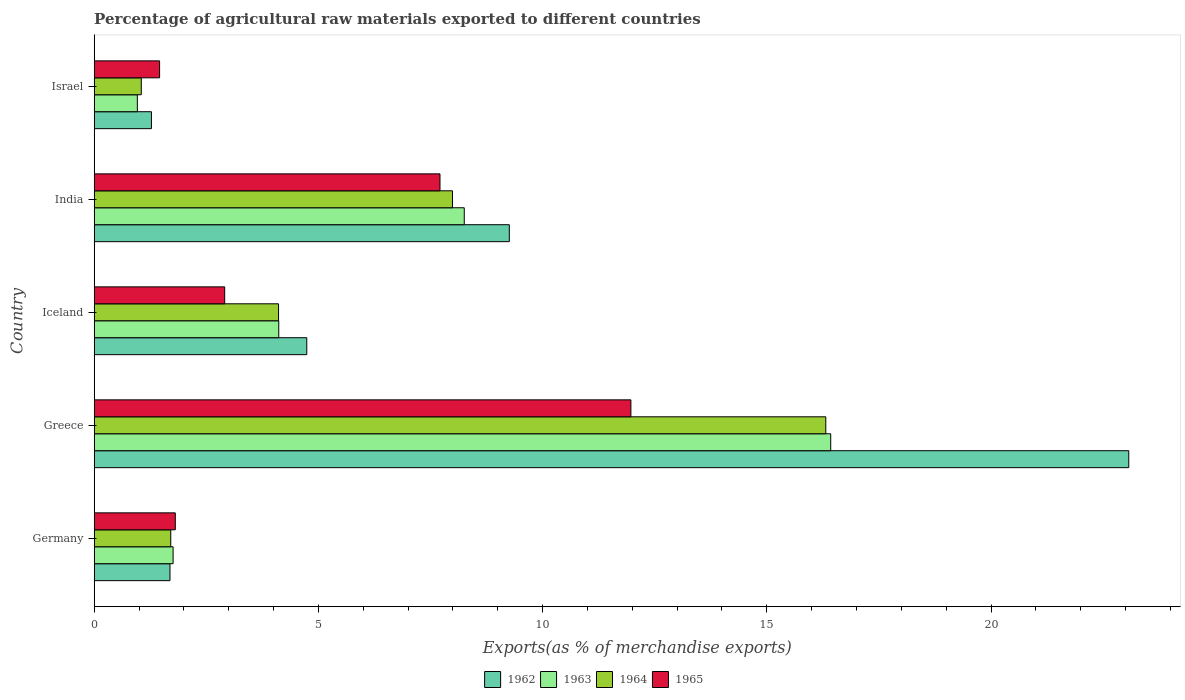Are the number of bars on each tick of the Y-axis equal?
Provide a short and direct response. Yes. How many bars are there on the 3rd tick from the top?
Provide a succinct answer. 4. How many bars are there on the 5th tick from the bottom?
Provide a succinct answer. 4. What is the label of the 1st group of bars from the top?
Provide a short and direct response. Israel. What is the percentage of exports to different countries in 1962 in Germany?
Your answer should be very brief. 1.69. Across all countries, what is the maximum percentage of exports to different countries in 1963?
Offer a very short reply. 16.43. Across all countries, what is the minimum percentage of exports to different countries in 1963?
Provide a short and direct response. 0.96. In which country was the percentage of exports to different countries in 1964 maximum?
Keep it short and to the point. Greece. In which country was the percentage of exports to different countries in 1962 minimum?
Make the answer very short. Israel. What is the total percentage of exports to different countries in 1964 in the graph?
Keep it short and to the point. 31.17. What is the difference between the percentage of exports to different countries in 1964 in Germany and that in Iceland?
Ensure brevity in your answer.  -2.4. What is the difference between the percentage of exports to different countries in 1963 in India and the percentage of exports to different countries in 1964 in Israel?
Your response must be concise. 7.2. What is the average percentage of exports to different countries in 1964 per country?
Your response must be concise. 6.23. What is the difference between the percentage of exports to different countries in 1962 and percentage of exports to different countries in 1963 in Israel?
Give a very brief answer. 0.31. In how many countries, is the percentage of exports to different countries in 1965 greater than 8 %?
Your response must be concise. 1. What is the ratio of the percentage of exports to different countries in 1962 in Greece to that in Israel?
Your response must be concise. 18.07. Is the difference between the percentage of exports to different countries in 1962 in Iceland and Israel greater than the difference between the percentage of exports to different countries in 1963 in Iceland and Israel?
Provide a short and direct response. Yes. What is the difference between the highest and the second highest percentage of exports to different countries in 1965?
Offer a very short reply. 4.26. What is the difference between the highest and the lowest percentage of exports to different countries in 1963?
Offer a terse response. 15.46. In how many countries, is the percentage of exports to different countries in 1963 greater than the average percentage of exports to different countries in 1963 taken over all countries?
Keep it short and to the point. 2. What does the 1st bar from the bottom in Germany represents?
Ensure brevity in your answer.  1962. Is it the case that in every country, the sum of the percentage of exports to different countries in 1962 and percentage of exports to different countries in 1965 is greater than the percentage of exports to different countries in 1963?
Your answer should be very brief. Yes. How many bars are there?
Offer a terse response. 20. Are all the bars in the graph horizontal?
Offer a very short reply. Yes. Are the values on the major ticks of X-axis written in scientific E-notation?
Offer a terse response. No. Does the graph contain any zero values?
Provide a succinct answer. No. Where does the legend appear in the graph?
Provide a succinct answer. Bottom center. How many legend labels are there?
Your answer should be very brief. 4. What is the title of the graph?
Your response must be concise. Percentage of agricultural raw materials exported to different countries. What is the label or title of the X-axis?
Provide a succinct answer. Exports(as % of merchandise exports). What is the label or title of the Y-axis?
Your answer should be compact. Country. What is the Exports(as % of merchandise exports) in 1962 in Germany?
Provide a short and direct response. 1.69. What is the Exports(as % of merchandise exports) in 1963 in Germany?
Provide a succinct answer. 1.76. What is the Exports(as % of merchandise exports) of 1964 in Germany?
Keep it short and to the point. 1.71. What is the Exports(as % of merchandise exports) of 1965 in Germany?
Your answer should be compact. 1.81. What is the Exports(as % of merchandise exports) of 1962 in Greece?
Make the answer very short. 23.07. What is the Exports(as % of merchandise exports) of 1963 in Greece?
Your answer should be compact. 16.43. What is the Exports(as % of merchandise exports) of 1964 in Greece?
Your answer should be compact. 16.32. What is the Exports(as % of merchandise exports) in 1965 in Greece?
Your response must be concise. 11.97. What is the Exports(as % of merchandise exports) of 1962 in Iceland?
Make the answer very short. 4.74. What is the Exports(as % of merchandise exports) of 1963 in Iceland?
Your answer should be very brief. 4.12. What is the Exports(as % of merchandise exports) of 1964 in Iceland?
Ensure brevity in your answer.  4.11. What is the Exports(as % of merchandise exports) in 1965 in Iceland?
Offer a very short reply. 2.91. What is the Exports(as % of merchandise exports) of 1962 in India?
Your answer should be compact. 9.26. What is the Exports(as % of merchandise exports) in 1963 in India?
Your answer should be compact. 8.25. What is the Exports(as % of merchandise exports) in 1964 in India?
Your answer should be compact. 7.99. What is the Exports(as % of merchandise exports) of 1965 in India?
Offer a very short reply. 7.71. What is the Exports(as % of merchandise exports) of 1962 in Israel?
Give a very brief answer. 1.28. What is the Exports(as % of merchandise exports) in 1963 in Israel?
Ensure brevity in your answer.  0.96. What is the Exports(as % of merchandise exports) of 1964 in Israel?
Ensure brevity in your answer.  1.05. What is the Exports(as % of merchandise exports) in 1965 in Israel?
Ensure brevity in your answer.  1.46. Across all countries, what is the maximum Exports(as % of merchandise exports) of 1962?
Keep it short and to the point. 23.07. Across all countries, what is the maximum Exports(as % of merchandise exports) in 1963?
Your response must be concise. 16.43. Across all countries, what is the maximum Exports(as % of merchandise exports) of 1964?
Offer a very short reply. 16.32. Across all countries, what is the maximum Exports(as % of merchandise exports) of 1965?
Provide a succinct answer. 11.97. Across all countries, what is the minimum Exports(as % of merchandise exports) in 1962?
Your answer should be very brief. 1.28. Across all countries, what is the minimum Exports(as % of merchandise exports) in 1963?
Your response must be concise. 0.96. Across all countries, what is the minimum Exports(as % of merchandise exports) in 1964?
Offer a terse response. 1.05. Across all countries, what is the minimum Exports(as % of merchandise exports) in 1965?
Ensure brevity in your answer.  1.46. What is the total Exports(as % of merchandise exports) in 1962 in the graph?
Your answer should be very brief. 40.04. What is the total Exports(as % of merchandise exports) of 1963 in the graph?
Keep it short and to the point. 31.52. What is the total Exports(as % of merchandise exports) in 1964 in the graph?
Keep it short and to the point. 31.17. What is the total Exports(as % of merchandise exports) of 1965 in the graph?
Provide a short and direct response. 25.86. What is the difference between the Exports(as % of merchandise exports) in 1962 in Germany and that in Greece?
Keep it short and to the point. -21.38. What is the difference between the Exports(as % of merchandise exports) of 1963 in Germany and that in Greece?
Your answer should be very brief. -14.67. What is the difference between the Exports(as % of merchandise exports) in 1964 in Germany and that in Greece?
Ensure brevity in your answer.  -14.61. What is the difference between the Exports(as % of merchandise exports) of 1965 in Germany and that in Greece?
Your answer should be compact. -10.16. What is the difference between the Exports(as % of merchandise exports) of 1962 in Germany and that in Iceland?
Keep it short and to the point. -3.05. What is the difference between the Exports(as % of merchandise exports) in 1963 in Germany and that in Iceland?
Keep it short and to the point. -2.36. What is the difference between the Exports(as % of merchandise exports) of 1964 in Germany and that in Iceland?
Make the answer very short. -2.4. What is the difference between the Exports(as % of merchandise exports) in 1965 in Germany and that in Iceland?
Your answer should be very brief. -1.1. What is the difference between the Exports(as % of merchandise exports) of 1962 in Germany and that in India?
Your answer should be compact. -7.57. What is the difference between the Exports(as % of merchandise exports) in 1963 in Germany and that in India?
Give a very brief answer. -6.49. What is the difference between the Exports(as % of merchandise exports) of 1964 in Germany and that in India?
Offer a terse response. -6.28. What is the difference between the Exports(as % of merchandise exports) of 1965 in Germany and that in India?
Provide a succinct answer. -5.9. What is the difference between the Exports(as % of merchandise exports) in 1962 in Germany and that in Israel?
Your answer should be very brief. 0.41. What is the difference between the Exports(as % of merchandise exports) of 1963 in Germany and that in Israel?
Your answer should be compact. 0.8. What is the difference between the Exports(as % of merchandise exports) in 1964 in Germany and that in Israel?
Offer a very short reply. 0.66. What is the difference between the Exports(as % of merchandise exports) in 1965 in Germany and that in Israel?
Make the answer very short. 0.35. What is the difference between the Exports(as % of merchandise exports) of 1962 in Greece and that in Iceland?
Offer a terse response. 18.33. What is the difference between the Exports(as % of merchandise exports) in 1963 in Greece and that in Iceland?
Your response must be concise. 12.31. What is the difference between the Exports(as % of merchandise exports) of 1964 in Greece and that in Iceland?
Keep it short and to the point. 12.2. What is the difference between the Exports(as % of merchandise exports) in 1965 in Greece and that in Iceland?
Offer a terse response. 9.06. What is the difference between the Exports(as % of merchandise exports) in 1962 in Greece and that in India?
Your answer should be compact. 13.81. What is the difference between the Exports(as % of merchandise exports) of 1963 in Greece and that in India?
Give a very brief answer. 8.17. What is the difference between the Exports(as % of merchandise exports) in 1964 in Greece and that in India?
Provide a short and direct response. 8.33. What is the difference between the Exports(as % of merchandise exports) of 1965 in Greece and that in India?
Your answer should be very brief. 4.26. What is the difference between the Exports(as % of merchandise exports) in 1962 in Greece and that in Israel?
Keep it short and to the point. 21.8. What is the difference between the Exports(as % of merchandise exports) in 1963 in Greece and that in Israel?
Provide a succinct answer. 15.46. What is the difference between the Exports(as % of merchandise exports) in 1964 in Greece and that in Israel?
Provide a short and direct response. 15.27. What is the difference between the Exports(as % of merchandise exports) in 1965 in Greece and that in Israel?
Ensure brevity in your answer.  10.51. What is the difference between the Exports(as % of merchandise exports) of 1962 in Iceland and that in India?
Make the answer very short. -4.52. What is the difference between the Exports(as % of merchandise exports) of 1963 in Iceland and that in India?
Your response must be concise. -4.14. What is the difference between the Exports(as % of merchandise exports) in 1964 in Iceland and that in India?
Offer a terse response. -3.88. What is the difference between the Exports(as % of merchandise exports) in 1965 in Iceland and that in India?
Provide a succinct answer. -4.8. What is the difference between the Exports(as % of merchandise exports) of 1962 in Iceland and that in Israel?
Ensure brevity in your answer.  3.46. What is the difference between the Exports(as % of merchandise exports) in 1963 in Iceland and that in Israel?
Provide a succinct answer. 3.15. What is the difference between the Exports(as % of merchandise exports) in 1964 in Iceland and that in Israel?
Make the answer very short. 3.06. What is the difference between the Exports(as % of merchandise exports) of 1965 in Iceland and that in Israel?
Make the answer very short. 1.45. What is the difference between the Exports(as % of merchandise exports) of 1962 in India and that in Israel?
Provide a short and direct response. 7.98. What is the difference between the Exports(as % of merchandise exports) of 1963 in India and that in Israel?
Your answer should be very brief. 7.29. What is the difference between the Exports(as % of merchandise exports) in 1964 in India and that in Israel?
Give a very brief answer. 6.94. What is the difference between the Exports(as % of merchandise exports) in 1965 in India and that in Israel?
Give a very brief answer. 6.25. What is the difference between the Exports(as % of merchandise exports) in 1962 in Germany and the Exports(as % of merchandise exports) in 1963 in Greece?
Your response must be concise. -14.74. What is the difference between the Exports(as % of merchandise exports) of 1962 in Germany and the Exports(as % of merchandise exports) of 1964 in Greece?
Give a very brief answer. -14.63. What is the difference between the Exports(as % of merchandise exports) in 1962 in Germany and the Exports(as % of merchandise exports) in 1965 in Greece?
Make the answer very short. -10.28. What is the difference between the Exports(as % of merchandise exports) of 1963 in Germany and the Exports(as % of merchandise exports) of 1964 in Greece?
Make the answer very short. -14.56. What is the difference between the Exports(as % of merchandise exports) of 1963 in Germany and the Exports(as % of merchandise exports) of 1965 in Greece?
Give a very brief answer. -10.21. What is the difference between the Exports(as % of merchandise exports) of 1964 in Germany and the Exports(as % of merchandise exports) of 1965 in Greece?
Your answer should be compact. -10.26. What is the difference between the Exports(as % of merchandise exports) in 1962 in Germany and the Exports(as % of merchandise exports) in 1963 in Iceland?
Provide a succinct answer. -2.43. What is the difference between the Exports(as % of merchandise exports) in 1962 in Germany and the Exports(as % of merchandise exports) in 1964 in Iceland?
Provide a short and direct response. -2.42. What is the difference between the Exports(as % of merchandise exports) of 1962 in Germany and the Exports(as % of merchandise exports) of 1965 in Iceland?
Your response must be concise. -1.22. What is the difference between the Exports(as % of merchandise exports) of 1963 in Germany and the Exports(as % of merchandise exports) of 1964 in Iceland?
Your response must be concise. -2.35. What is the difference between the Exports(as % of merchandise exports) in 1963 in Germany and the Exports(as % of merchandise exports) in 1965 in Iceland?
Make the answer very short. -1.15. What is the difference between the Exports(as % of merchandise exports) in 1964 in Germany and the Exports(as % of merchandise exports) in 1965 in Iceland?
Offer a very short reply. -1.2. What is the difference between the Exports(as % of merchandise exports) of 1962 in Germany and the Exports(as % of merchandise exports) of 1963 in India?
Your response must be concise. -6.56. What is the difference between the Exports(as % of merchandise exports) of 1962 in Germany and the Exports(as % of merchandise exports) of 1964 in India?
Offer a very short reply. -6.3. What is the difference between the Exports(as % of merchandise exports) in 1962 in Germany and the Exports(as % of merchandise exports) in 1965 in India?
Give a very brief answer. -6.02. What is the difference between the Exports(as % of merchandise exports) of 1963 in Germany and the Exports(as % of merchandise exports) of 1964 in India?
Keep it short and to the point. -6.23. What is the difference between the Exports(as % of merchandise exports) of 1963 in Germany and the Exports(as % of merchandise exports) of 1965 in India?
Offer a terse response. -5.95. What is the difference between the Exports(as % of merchandise exports) in 1964 in Germany and the Exports(as % of merchandise exports) in 1965 in India?
Your response must be concise. -6. What is the difference between the Exports(as % of merchandise exports) of 1962 in Germany and the Exports(as % of merchandise exports) of 1963 in Israel?
Keep it short and to the point. 0.73. What is the difference between the Exports(as % of merchandise exports) of 1962 in Germany and the Exports(as % of merchandise exports) of 1964 in Israel?
Ensure brevity in your answer.  0.64. What is the difference between the Exports(as % of merchandise exports) of 1962 in Germany and the Exports(as % of merchandise exports) of 1965 in Israel?
Provide a succinct answer. 0.23. What is the difference between the Exports(as % of merchandise exports) in 1963 in Germany and the Exports(as % of merchandise exports) in 1964 in Israel?
Provide a short and direct response. 0.71. What is the difference between the Exports(as % of merchandise exports) in 1963 in Germany and the Exports(as % of merchandise exports) in 1965 in Israel?
Keep it short and to the point. 0.3. What is the difference between the Exports(as % of merchandise exports) of 1964 in Germany and the Exports(as % of merchandise exports) of 1965 in Israel?
Ensure brevity in your answer.  0.25. What is the difference between the Exports(as % of merchandise exports) of 1962 in Greece and the Exports(as % of merchandise exports) of 1963 in Iceland?
Make the answer very short. 18.96. What is the difference between the Exports(as % of merchandise exports) in 1962 in Greece and the Exports(as % of merchandise exports) in 1964 in Iceland?
Your answer should be very brief. 18.96. What is the difference between the Exports(as % of merchandise exports) in 1962 in Greece and the Exports(as % of merchandise exports) in 1965 in Iceland?
Your answer should be very brief. 20.16. What is the difference between the Exports(as % of merchandise exports) in 1963 in Greece and the Exports(as % of merchandise exports) in 1964 in Iceland?
Make the answer very short. 12.31. What is the difference between the Exports(as % of merchandise exports) in 1963 in Greece and the Exports(as % of merchandise exports) in 1965 in Iceland?
Offer a terse response. 13.52. What is the difference between the Exports(as % of merchandise exports) in 1964 in Greece and the Exports(as % of merchandise exports) in 1965 in Iceland?
Your response must be concise. 13.41. What is the difference between the Exports(as % of merchandise exports) in 1962 in Greece and the Exports(as % of merchandise exports) in 1963 in India?
Offer a very short reply. 14.82. What is the difference between the Exports(as % of merchandise exports) of 1962 in Greece and the Exports(as % of merchandise exports) of 1964 in India?
Offer a very short reply. 15.08. What is the difference between the Exports(as % of merchandise exports) in 1962 in Greece and the Exports(as % of merchandise exports) in 1965 in India?
Provide a short and direct response. 15.36. What is the difference between the Exports(as % of merchandise exports) of 1963 in Greece and the Exports(as % of merchandise exports) of 1964 in India?
Offer a very short reply. 8.44. What is the difference between the Exports(as % of merchandise exports) of 1963 in Greece and the Exports(as % of merchandise exports) of 1965 in India?
Your response must be concise. 8.71. What is the difference between the Exports(as % of merchandise exports) of 1964 in Greece and the Exports(as % of merchandise exports) of 1965 in India?
Provide a succinct answer. 8.6. What is the difference between the Exports(as % of merchandise exports) in 1962 in Greece and the Exports(as % of merchandise exports) in 1963 in Israel?
Give a very brief answer. 22.11. What is the difference between the Exports(as % of merchandise exports) in 1962 in Greece and the Exports(as % of merchandise exports) in 1964 in Israel?
Ensure brevity in your answer.  22.02. What is the difference between the Exports(as % of merchandise exports) in 1962 in Greece and the Exports(as % of merchandise exports) in 1965 in Israel?
Provide a short and direct response. 21.61. What is the difference between the Exports(as % of merchandise exports) in 1963 in Greece and the Exports(as % of merchandise exports) in 1964 in Israel?
Provide a succinct answer. 15.38. What is the difference between the Exports(as % of merchandise exports) of 1963 in Greece and the Exports(as % of merchandise exports) of 1965 in Israel?
Your answer should be compact. 14.97. What is the difference between the Exports(as % of merchandise exports) of 1964 in Greece and the Exports(as % of merchandise exports) of 1965 in Israel?
Offer a very short reply. 14.86. What is the difference between the Exports(as % of merchandise exports) in 1962 in Iceland and the Exports(as % of merchandise exports) in 1963 in India?
Provide a short and direct response. -3.51. What is the difference between the Exports(as % of merchandise exports) of 1962 in Iceland and the Exports(as % of merchandise exports) of 1964 in India?
Ensure brevity in your answer.  -3.25. What is the difference between the Exports(as % of merchandise exports) of 1962 in Iceland and the Exports(as % of merchandise exports) of 1965 in India?
Give a very brief answer. -2.97. What is the difference between the Exports(as % of merchandise exports) of 1963 in Iceland and the Exports(as % of merchandise exports) of 1964 in India?
Give a very brief answer. -3.87. What is the difference between the Exports(as % of merchandise exports) of 1963 in Iceland and the Exports(as % of merchandise exports) of 1965 in India?
Provide a succinct answer. -3.6. What is the difference between the Exports(as % of merchandise exports) of 1964 in Iceland and the Exports(as % of merchandise exports) of 1965 in India?
Give a very brief answer. -3.6. What is the difference between the Exports(as % of merchandise exports) of 1962 in Iceland and the Exports(as % of merchandise exports) of 1963 in Israel?
Offer a terse response. 3.78. What is the difference between the Exports(as % of merchandise exports) in 1962 in Iceland and the Exports(as % of merchandise exports) in 1964 in Israel?
Ensure brevity in your answer.  3.69. What is the difference between the Exports(as % of merchandise exports) of 1962 in Iceland and the Exports(as % of merchandise exports) of 1965 in Israel?
Offer a very short reply. 3.28. What is the difference between the Exports(as % of merchandise exports) in 1963 in Iceland and the Exports(as % of merchandise exports) in 1964 in Israel?
Ensure brevity in your answer.  3.07. What is the difference between the Exports(as % of merchandise exports) of 1963 in Iceland and the Exports(as % of merchandise exports) of 1965 in Israel?
Offer a terse response. 2.66. What is the difference between the Exports(as % of merchandise exports) of 1964 in Iceland and the Exports(as % of merchandise exports) of 1965 in Israel?
Keep it short and to the point. 2.65. What is the difference between the Exports(as % of merchandise exports) in 1962 in India and the Exports(as % of merchandise exports) in 1963 in Israel?
Give a very brief answer. 8.3. What is the difference between the Exports(as % of merchandise exports) of 1962 in India and the Exports(as % of merchandise exports) of 1964 in Israel?
Offer a very short reply. 8.21. What is the difference between the Exports(as % of merchandise exports) in 1962 in India and the Exports(as % of merchandise exports) in 1965 in Israel?
Provide a short and direct response. 7.8. What is the difference between the Exports(as % of merchandise exports) of 1963 in India and the Exports(as % of merchandise exports) of 1964 in Israel?
Your answer should be compact. 7.2. What is the difference between the Exports(as % of merchandise exports) in 1963 in India and the Exports(as % of merchandise exports) in 1965 in Israel?
Give a very brief answer. 6.79. What is the difference between the Exports(as % of merchandise exports) in 1964 in India and the Exports(as % of merchandise exports) in 1965 in Israel?
Your response must be concise. 6.53. What is the average Exports(as % of merchandise exports) in 1962 per country?
Keep it short and to the point. 8.01. What is the average Exports(as % of merchandise exports) of 1963 per country?
Your answer should be very brief. 6.3. What is the average Exports(as % of merchandise exports) of 1964 per country?
Offer a very short reply. 6.23. What is the average Exports(as % of merchandise exports) of 1965 per country?
Ensure brevity in your answer.  5.17. What is the difference between the Exports(as % of merchandise exports) of 1962 and Exports(as % of merchandise exports) of 1963 in Germany?
Make the answer very short. -0.07. What is the difference between the Exports(as % of merchandise exports) in 1962 and Exports(as % of merchandise exports) in 1964 in Germany?
Provide a succinct answer. -0.02. What is the difference between the Exports(as % of merchandise exports) in 1962 and Exports(as % of merchandise exports) in 1965 in Germany?
Offer a terse response. -0.12. What is the difference between the Exports(as % of merchandise exports) in 1963 and Exports(as % of merchandise exports) in 1964 in Germany?
Offer a very short reply. 0.05. What is the difference between the Exports(as % of merchandise exports) in 1963 and Exports(as % of merchandise exports) in 1965 in Germany?
Make the answer very short. -0.05. What is the difference between the Exports(as % of merchandise exports) of 1964 and Exports(as % of merchandise exports) of 1965 in Germany?
Offer a terse response. -0.1. What is the difference between the Exports(as % of merchandise exports) in 1962 and Exports(as % of merchandise exports) in 1963 in Greece?
Offer a very short reply. 6.65. What is the difference between the Exports(as % of merchandise exports) in 1962 and Exports(as % of merchandise exports) in 1964 in Greece?
Give a very brief answer. 6.76. What is the difference between the Exports(as % of merchandise exports) of 1962 and Exports(as % of merchandise exports) of 1965 in Greece?
Your answer should be very brief. 11.1. What is the difference between the Exports(as % of merchandise exports) in 1963 and Exports(as % of merchandise exports) in 1964 in Greece?
Give a very brief answer. 0.11. What is the difference between the Exports(as % of merchandise exports) of 1963 and Exports(as % of merchandise exports) of 1965 in Greece?
Give a very brief answer. 4.46. What is the difference between the Exports(as % of merchandise exports) of 1964 and Exports(as % of merchandise exports) of 1965 in Greece?
Your answer should be very brief. 4.35. What is the difference between the Exports(as % of merchandise exports) of 1962 and Exports(as % of merchandise exports) of 1963 in Iceland?
Your answer should be compact. 0.63. What is the difference between the Exports(as % of merchandise exports) in 1962 and Exports(as % of merchandise exports) in 1964 in Iceland?
Give a very brief answer. 0.63. What is the difference between the Exports(as % of merchandise exports) of 1962 and Exports(as % of merchandise exports) of 1965 in Iceland?
Ensure brevity in your answer.  1.83. What is the difference between the Exports(as % of merchandise exports) in 1963 and Exports(as % of merchandise exports) in 1964 in Iceland?
Give a very brief answer. 0. What is the difference between the Exports(as % of merchandise exports) of 1963 and Exports(as % of merchandise exports) of 1965 in Iceland?
Your answer should be very brief. 1.21. What is the difference between the Exports(as % of merchandise exports) of 1964 and Exports(as % of merchandise exports) of 1965 in Iceland?
Provide a short and direct response. 1.2. What is the difference between the Exports(as % of merchandise exports) in 1962 and Exports(as % of merchandise exports) in 1963 in India?
Keep it short and to the point. 1. What is the difference between the Exports(as % of merchandise exports) in 1962 and Exports(as % of merchandise exports) in 1964 in India?
Your response must be concise. 1.27. What is the difference between the Exports(as % of merchandise exports) in 1962 and Exports(as % of merchandise exports) in 1965 in India?
Offer a terse response. 1.55. What is the difference between the Exports(as % of merchandise exports) of 1963 and Exports(as % of merchandise exports) of 1964 in India?
Give a very brief answer. 0.26. What is the difference between the Exports(as % of merchandise exports) of 1963 and Exports(as % of merchandise exports) of 1965 in India?
Provide a short and direct response. 0.54. What is the difference between the Exports(as % of merchandise exports) of 1964 and Exports(as % of merchandise exports) of 1965 in India?
Provide a short and direct response. 0.28. What is the difference between the Exports(as % of merchandise exports) in 1962 and Exports(as % of merchandise exports) in 1963 in Israel?
Your response must be concise. 0.31. What is the difference between the Exports(as % of merchandise exports) in 1962 and Exports(as % of merchandise exports) in 1964 in Israel?
Give a very brief answer. 0.23. What is the difference between the Exports(as % of merchandise exports) of 1962 and Exports(as % of merchandise exports) of 1965 in Israel?
Keep it short and to the point. -0.18. What is the difference between the Exports(as % of merchandise exports) of 1963 and Exports(as % of merchandise exports) of 1964 in Israel?
Your response must be concise. -0.09. What is the difference between the Exports(as % of merchandise exports) of 1963 and Exports(as % of merchandise exports) of 1965 in Israel?
Offer a very short reply. -0.5. What is the difference between the Exports(as % of merchandise exports) in 1964 and Exports(as % of merchandise exports) in 1965 in Israel?
Provide a short and direct response. -0.41. What is the ratio of the Exports(as % of merchandise exports) in 1962 in Germany to that in Greece?
Keep it short and to the point. 0.07. What is the ratio of the Exports(as % of merchandise exports) in 1963 in Germany to that in Greece?
Make the answer very short. 0.11. What is the ratio of the Exports(as % of merchandise exports) in 1964 in Germany to that in Greece?
Offer a terse response. 0.1. What is the ratio of the Exports(as % of merchandise exports) of 1965 in Germany to that in Greece?
Your response must be concise. 0.15. What is the ratio of the Exports(as % of merchandise exports) in 1962 in Germany to that in Iceland?
Make the answer very short. 0.36. What is the ratio of the Exports(as % of merchandise exports) of 1963 in Germany to that in Iceland?
Make the answer very short. 0.43. What is the ratio of the Exports(as % of merchandise exports) in 1964 in Germany to that in Iceland?
Give a very brief answer. 0.42. What is the ratio of the Exports(as % of merchandise exports) of 1965 in Germany to that in Iceland?
Your response must be concise. 0.62. What is the ratio of the Exports(as % of merchandise exports) in 1962 in Germany to that in India?
Provide a short and direct response. 0.18. What is the ratio of the Exports(as % of merchandise exports) of 1963 in Germany to that in India?
Your answer should be compact. 0.21. What is the ratio of the Exports(as % of merchandise exports) of 1964 in Germany to that in India?
Ensure brevity in your answer.  0.21. What is the ratio of the Exports(as % of merchandise exports) in 1965 in Germany to that in India?
Your answer should be compact. 0.23. What is the ratio of the Exports(as % of merchandise exports) of 1962 in Germany to that in Israel?
Give a very brief answer. 1.32. What is the ratio of the Exports(as % of merchandise exports) of 1963 in Germany to that in Israel?
Ensure brevity in your answer.  1.83. What is the ratio of the Exports(as % of merchandise exports) in 1964 in Germany to that in Israel?
Your response must be concise. 1.63. What is the ratio of the Exports(as % of merchandise exports) of 1965 in Germany to that in Israel?
Provide a short and direct response. 1.24. What is the ratio of the Exports(as % of merchandise exports) in 1962 in Greece to that in Iceland?
Provide a short and direct response. 4.87. What is the ratio of the Exports(as % of merchandise exports) in 1963 in Greece to that in Iceland?
Keep it short and to the point. 3.99. What is the ratio of the Exports(as % of merchandise exports) in 1964 in Greece to that in Iceland?
Your answer should be compact. 3.97. What is the ratio of the Exports(as % of merchandise exports) of 1965 in Greece to that in Iceland?
Your response must be concise. 4.11. What is the ratio of the Exports(as % of merchandise exports) of 1962 in Greece to that in India?
Your response must be concise. 2.49. What is the ratio of the Exports(as % of merchandise exports) of 1963 in Greece to that in India?
Ensure brevity in your answer.  1.99. What is the ratio of the Exports(as % of merchandise exports) of 1964 in Greece to that in India?
Keep it short and to the point. 2.04. What is the ratio of the Exports(as % of merchandise exports) in 1965 in Greece to that in India?
Keep it short and to the point. 1.55. What is the ratio of the Exports(as % of merchandise exports) of 1962 in Greece to that in Israel?
Keep it short and to the point. 18.07. What is the ratio of the Exports(as % of merchandise exports) in 1963 in Greece to that in Israel?
Give a very brief answer. 17.07. What is the ratio of the Exports(as % of merchandise exports) in 1964 in Greece to that in Israel?
Provide a succinct answer. 15.54. What is the ratio of the Exports(as % of merchandise exports) of 1965 in Greece to that in Israel?
Your answer should be very brief. 8.21. What is the ratio of the Exports(as % of merchandise exports) in 1962 in Iceland to that in India?
Your answer should be very brief. 0.51. What is the ratio of the Exports(as % of merchandise exports) in 1963 in Iceland to that in India?
Keep it short and to the point. 0.5. What is the ratio of the Exports(as % of merchandise exports) of 1964 in Iceland to that in India?
Give a very brief answer. 0.51. What is the ratio of the Exports(as % of merchandise exports) in 1965 in Iceland to that in India?
Your answer should be very brief. 0.38. What is the ratio of the Exports(as % of merchandise exports) in 1962 in Iceland to that in Israel?
Your answer should be very brief. 3.71. What is the ratio of the Exports(as % of merchandise exports) of 1963 in Iceland to that in Israel?
Give a very brief answer. 4.28. What is the ratio of the Exports(as % of merchandise exports) in 1964 in Iceland to that in Israel?
Your answer should be compact. 3.92. What is the ratio of the Exports(as % of merchandise exports) of 1965 in Iceland to that in Israel?
Give a very brief answer. 2. What is the ratio of the Exports(as % of merchandise exports) of 1962 in India to that in Israel?
Provide a succinct answer. 7.25. What is the ratio of the Exports(as % of merchandise exports) in 1963 in India to that in Israel?
Your answer should be very brief. 8.58. What is the ratio of the Exports(as % of merchandise exports) of 1964 in India to that in Israel?
Offer a very short reply. 7.61. What is the ratio of the Exports(as % of merchandise exports) of 1965 in India to that in Israel?
Your answer should be compact. 5.29. What is the difference between the highest and the second highest Exports(as % of merchandise exports) in 1962?
Your answer should be very brief. 13.81. What is the difference between the highest and the second highest Exports(as % of merchandise exports) of 1963?
Offer a terse response. 8.17. What is the difference between the highest and the second highest Exports(as % of merchandise exports) of 1964?
Offer a terse response. 8.33. What is the difference between the highest and the second highest Exports(as % of merchandise exports) in 1965?
Keep it short and to the point. 4.26. What is the difference between the highest and the lowest Exports(as % of merchandise exports) in 1962?
Offer a very short reply. 21.8. What is the difference between the highest and the lowest Exports(as % of merchandise exports) of 1963?
Provide a short and direct response. 15.46. What is the difference between the highest and the lowest Exports(as % of merchandise exports) of 1964?
Give a very brief answer. 15.27. What is the difference between the highest and the lowest Exports(as % of merchandise exports) of 1965?
Give a very brief answer. 10.51. 